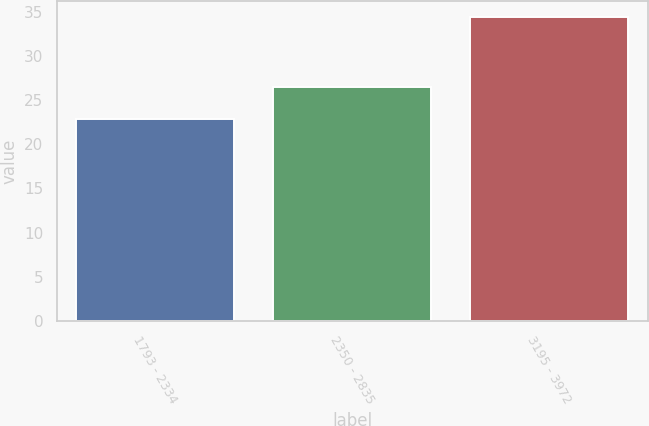Convert chart. <chart><loc_0><loc_0><loc_500><loc_500><bar_chart><fcel>1793 - 2334<fcel>2350 - 2835<fcel>3195 - 3972<nl><fcel>22.93<fcel>26.56<fcel>34.49<nl></chart> 